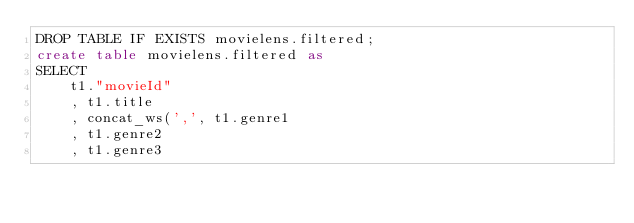Convert code to text. <code><loc_0><loc_0><loc_500><loc_500><_SQL_>DROP TABLE IF EXISTS movielens.filtered;
create table movielens.filtered as 
SELECT 
    t1."movieId" 
    , t1.title
    , concat_ws(',', t1.genre1
    , t1.genre2
    , t1.genre3</code> 